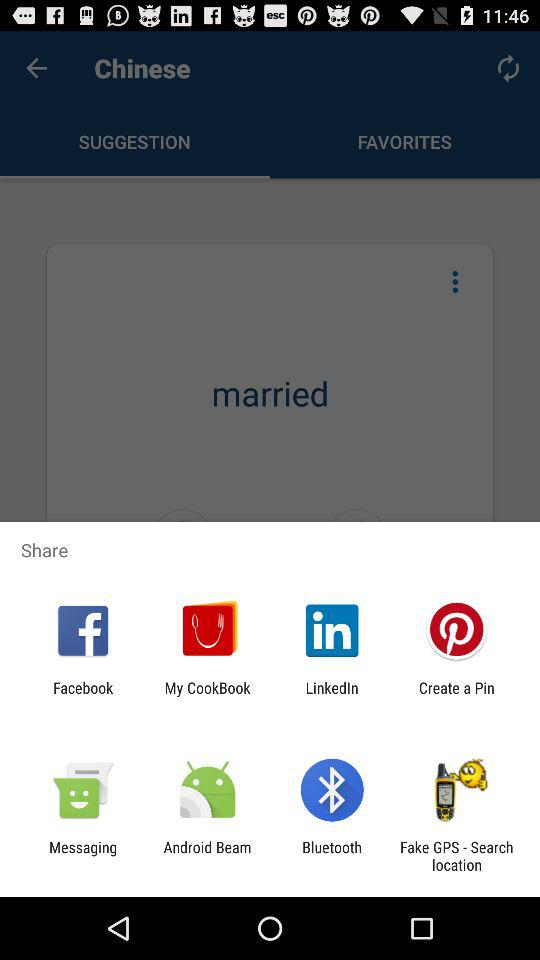What are the sharing options? The sharing options are "Facebook", "My CookBook", "LinkedIn", "Create a Pin", "Messaging", "Android Beam", "Bluetooth" and "Fake GPS - Search location". 